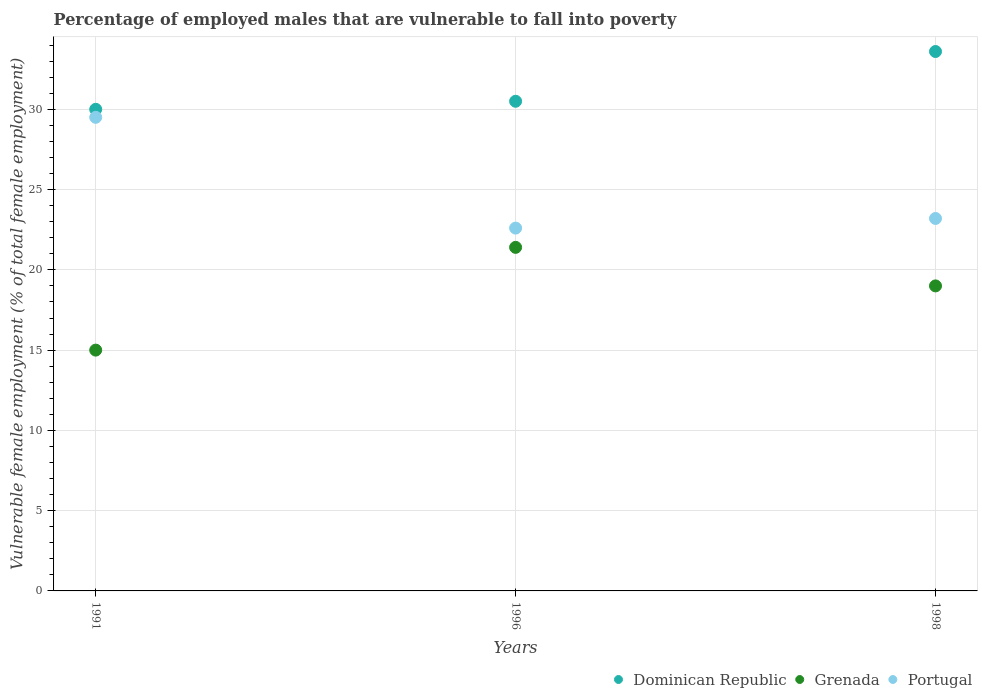How many different coloured dotlines are there?
Give a very brief answer. 3. What is the percentage of employed males who are vulnerable to fall into poverty in Dominican Republic in 1991?
Offer a very short reply. 30. Across all years, what is the maximum percentage of employed males who are vulnerable to fall into poverty in Grenada?
Your response must be concise. 21.4. Across all years, what is the minimum percentage of employed males who are vulnerable to fall into poverty in Dominican Republic?
Your response must be concise. 30. In which year was the percentage of employed males who are vulnerable to fall into poverty in Dominican Republic minimum?
Your answer should be very brief. 1991. What is the total percentage of employed males who are vulnerable to fall into poverty in Portugal in the graph?
Offer a terse response. 75.3. What is the difference between the percentage of employed males who are vulnerable to fall into poverty in Portugal in 1991 and that in 1998?
Give a very brief answer. 6.3. What is the difference between the percentage of employed males who are vulnerable to fall into poverty in Portugal in 1998 and the percentage of employed males who are vulnerable to fall into poverty in Dominican Republic in 1996?
Make the answer very short. -7.3. What is the average percentage of employed males who are vulnerable to fall into poverty in Portugal per year?
Keep it short and to the point. 25.1. In the year 1998, what is the difference between the percentage of employed males who are vulnerable to fall into poverty in Portugal and percentage of employed males who are vulnerable to fall into poverty in Dominican Republic?
Offer a terse response. -10.4. What is the ratio of the percentage of employed males who are vulnerable to fall into poverty in Grenada in 1991 to that in 1996?
Your answer should be very brief. 0.7. Is the percentage of employed males who are vulnerable to fall into poverty in Portugal in 1991 less than that in 1996?
Make the answer very short. No. Is the difference between the percentage of employed males who are vulnerable to fall into poverty in Portugal in 1991 and 1998 greater than the difference between the percentage of employed males who are vulnerable to fall into poverty in Dominican Republic in 1991 and 1998?
Ensure brevity in your answer.  Yes. What is the difference between the highest and the second highest percentage of employed males who are vulnerable to fall into poverty in Portugal?
Provide a short and direct response. 6.3. What is the difference between the highest and the lowest percentage of employed males who are vulnerable to fall into poverty in Grenada?
Provide a short and direct response. 6.4. Does the percentage of employed males who are vulnerable to fall into poverty in Portugal monotonically increase over the years?
Provide a short and direct response. No. Is the percentage of employed males who are vulnerable to fall into poverty in Grenada strictly greater than the percentage of employed males who are vulnerable to fall into poverty in Portugal over the years?
Your answer should be compact. No. Are the values on the major ticks of Y-axis written in scientific E-notation?
Offer a very short reply. No. Does the graph contain grids?
Ensure brevity in your answer.  Yes. Where does the legend appear in the graph?
Your answer should be very brief. Bottom right. What is the title of the graph?
Your answer should be very brief. Percentage of employed males that are vulnerable to fall into poverty. Does "Switzerland" appear as one of the legend labels in the graph?
Your answer should be very brief. No. What is the label or title of the Y-axis?
Your answer should be compact. Vulnerable female employment (% of total female employment). What is the Vulnerable female employment (% of total female employment) in Dominican Republic in 1991?
Ensure brevity in your answer.  30. What is the Vulnerable female employment (% of total female employment) in Portugal in 1991?
Ensure brevity in your answer.  29.5. What is the Vulnerable female employment (% of total female employment) in Dominican Republic in 1996?
Provide a short and direct response. 30.5. What is the Vulnerable female employment (% of total female employment) in Grenada in 1996?
Give a very brief answer. 21.4. What is the Vulnerable female employment (% of total female employment) of Portugal in 1996?
Your response must be concise. 22.6. What is the Vulnerable female employment (% of total female employment) in Dominican Republic in 1998?
Make the answer very short. 33.6. What is the Vulnerable female employment (% of total female employment) of Portugal in 1998?
Offer a terse response. 23.2. Across all years, what is the maximum Vulnerable female employment (% of total female employment) of Dominican Republic?
Your response must be concise. 33.6. Across all years, what is the maximum Vulnerable female employment (% of total female employment) in Grenada?
Offer a terse response. 21.4. Across all years, what is the maximum Vulnerable female employment (% of total female employment) of Portugal?
Provide a short and direct response. 29.5. Across all years, what is the minimum Vulnerable female employment (% of total female employment) in Dominican Republic?
Keep it short and to the point. 30. Across all years, what is the minimum Vulnerable female employment (% of total female employment) in Portugal?
Make the answer very short. 22.6. What is the total Vulnerable female employment (% of total female employment) of Dominican Republic in the graph?
Provide a succinct answer. 94.1. What is the total Vulnerable female employment (% of total female employment) in Grenada in the graph?
Your answer should be compact. 55.4. What is the total Vulnerable female employment (% of total female employment) of Portugal in the graph?
Your answer should be very brief. 75.3. What is the difference between the Vulnerable female employment (% of total female employment) of Dominican Republic in 1991 and that in 1996?
Offer a terse response. -0.5. What is the difference between the Vulnerable female employment (% of total female employment) in Dominican Republic in 1991 and that in 1998?
Your response must be concise. -3.6. What is the difference between the Vulnerable female employment (% of total female employment) in Grenada in 1991 and that in 1998?
Make the answer very short. -4. What is the difference between the Vulnerable female employment (% of total female employment) of Dominican Republic in 1991 and the Vulnerable female employment (% of total female employment) of Portugal in 1996?
Keep it short and to the point. 7.4. What is the difference between the Vulnerable female employment (% of total female employment) in Dominican Republic in 1991 and the Vulnerable female employment (% of total female employment) in Grenada in 1998?
Offer a terse response. 11. What is the difference between the Vulnerable female employment (% of total female employment) in Dominican Republic in 1991 and the Vulnerable female employment (% of total female employment) in Portugal in 1998?
Your answer should be very brief. 6.8. What is the difference between the Vulnerable female employment (% of total female employment) of Grenada in 1991 and the Vulnerable female employment (% of total female employment) of Portugal in 1998?
Your answer should be very brief. -8.2. What is the difference between the Vulnerable female employment (% of total female employment) of Dominican Republic in 1996 and the Vulnerable female employment (% of total female employment) of Grenada in 1998?
Ensure brevity in your answer.  11.5. What is the average Vulnerable female employment (% of total female employment) of Dominican Republic per year?
Make the answer very short. 31.37. What is the average Vulnerable female employment (% of total female employment) in Grenada per year?
Ensure brevity in your answer.  18.47. What is the average Vulnerable female employment (% of total female employment) of Portugal per year?
Offer a terse response. 25.1. In the year 1991, what is the difference between the Vulnerable female employment (% of total female employment) of Dominican Republic and Vulnerable female employment (% of total female employment) of Grenada?
Provide a succinct answer. 15. In the year 1996, what is the difference between the Vulnerable female employment (% of total female employment) in Grenada and Vulnerable female employment (% of total female employment) in Portugal?
Offer a very short reply. -1.2. In the year 1998, what is the difference between the Vulnerable female employment (% of total female employment) of Grenada and Vulnerable female employment (% of total female employment) of Portugal?
Provide a short and direct response. -4.2. What is the ratio of the Vulnerable female employment (% of total female employment) of Dominican Republic in 1991 to that in 1996?
Provide a short and direct response. 0.98. What is the ratio of the Vulnerable female employment (% of total female employment) of Grenada in 1991 to that in 1996?
Offer a very short reply. 0.7. What is the ratio of the Vulnerable female employment (% of total female employment) of Portugal in 1991 to that in 1996?
Provide a short and direct response. 1.31. What is the ratio of the Vulnerable female employment (% of total female employment) of Dominican Republic in 1991 to that in 1998?
Provide a short and direct response. 0.89. What is the ratio of the Vulnerable female employment (% of total female employment) in Grenada in 1991 to that in 1998?
Ensure brevity in your answer.  0.79. What is the ratio of the Vulnerable female employment (% of total female employment) in Portugal in 1991 to that in 1998?
Offer a terse response. 1.27. What is the ratio of the Vulnerable female employment (% of total female employment) of Dominican Republic in 1996 to that in 1998?
Provide a succinct answer. 0.91. What is the ratio of the Vulnerable female employment (% of total female employment) in Grenada in 1996 to that in 1998?
Your answer should be very brief. 1.13. What is the ratio of the Vulnerable female employment (% of total female employment) of Portugal in 1996 to that in 1998?
Your response must be concise. 0.97. What is the difference between the highest and the second highest Vulnerable female employment (% of total female employment) of Grenada?
Provide a short and direct response. 2.4. What is the difference between the highest and the lowest Vulnerable female employment (% of total female employment) of Portugal?
Make the answer very short. 6.9. 